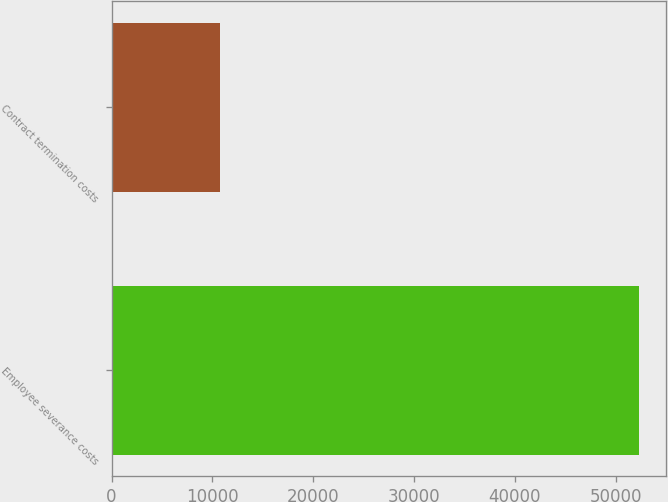Convert chart. <chart><loc_0><loc_0><loc_500><loc_500><bar_chart><fcel>Employee severance costs<fcel>Contract termination costs<nl><fcel>52344<fcel>10731<nl></chart> 